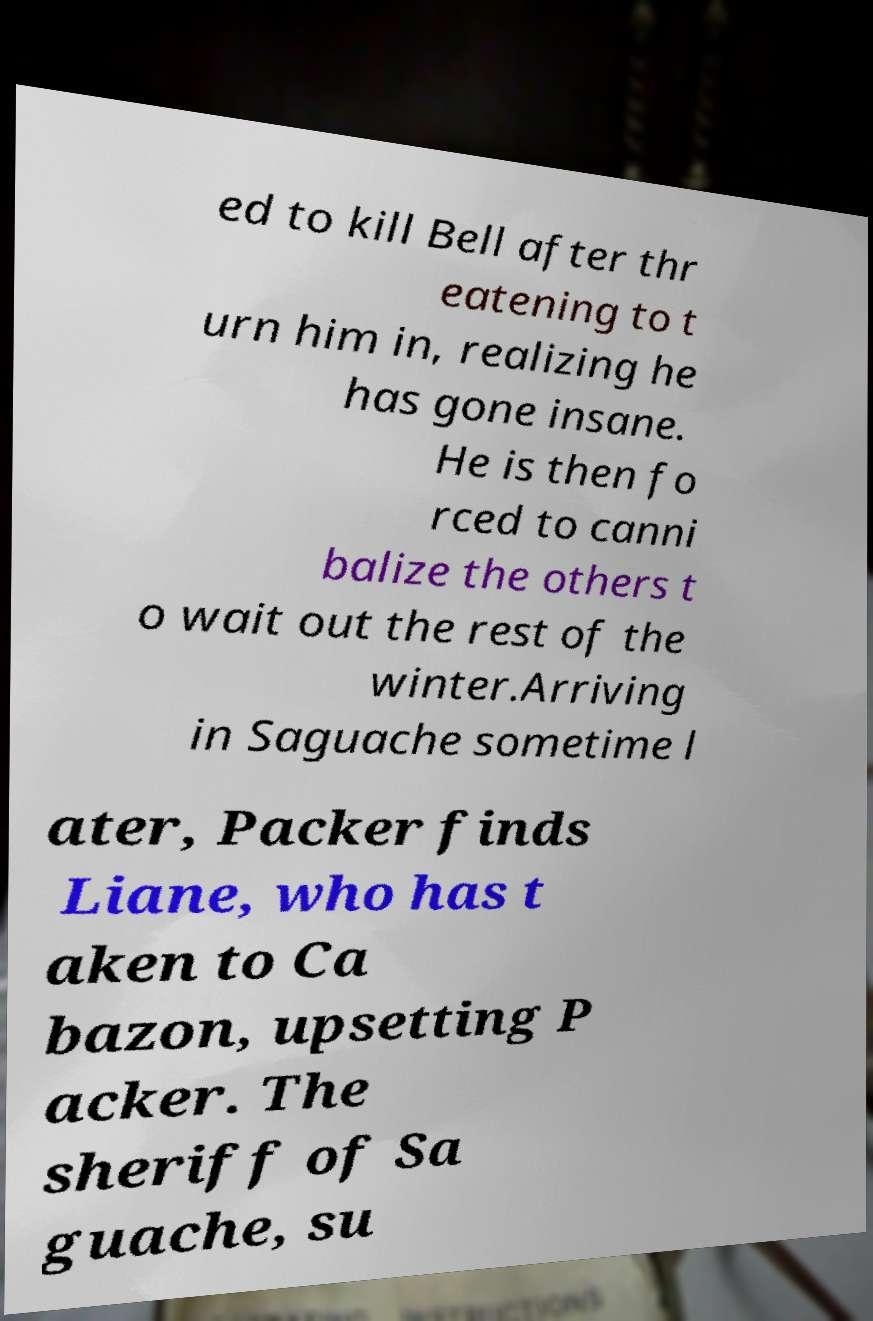What messages or text are displayed in this image? I need them in a readable, typed format. ed to kill Bell after thr eatening to t urn him in, realizing he has gone insane. He is then fo rced to canni balize the others t o wait out the rest of the winter.Arriving in Saguache sometime l ater, Packer finds Liane, who has t aken to Ca bazon, upsetting P acker. The sheriff of Sa guache, su 